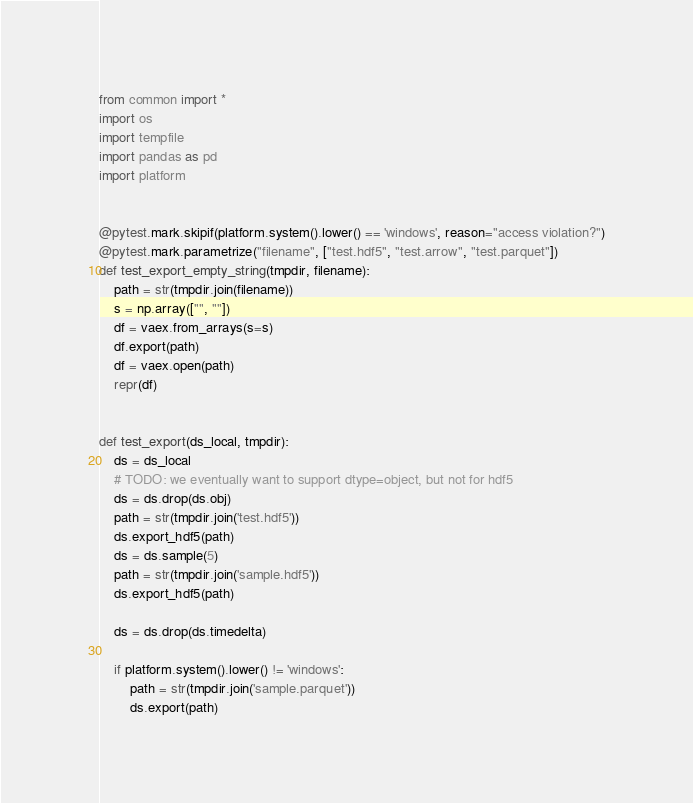Convert code to text. <code><loc_0><loc_0><loc_500><loc_500><_Python_>from common import *
import os
import tempfile
import pandas as pd
import platform


@pytest.mark.skipif(platform.system().lower() == 'windows', reason="access violation?")
@pytest.mark.parametrize("filename", ["test.hdf5", "test.arrow", "test.parquet"])
def test_export_empty_string(tmpdir, filename):
    path = str(tmpdir.join(filename))
    s = np.array(["", ""])
    df = vaex.from_arrays(s=s)
    df.export(path)
    df = vaex.open(path)
    repr(df)


def test_export(ds_local, tmpdir):
    ds = ds_local
    # TODO: we eventually want to support dtype=object, but not for hdf5
    ds = ds.drop(ds.obj)
    path = str(tmpdir.join('test.hdf5'))
    ds.export_hdf5(path)
    ds = ds.sample(5)
    path = str(tmpdir.join('sample.hdf5'))
    ds.export_hdf5(path)

    ds = ds.drop(ds.timedelta)

    if platform.system().lower() != 'windows':
        path = str(tmpdir.join('sample.parquet'))
        ds.export(path)</code> 